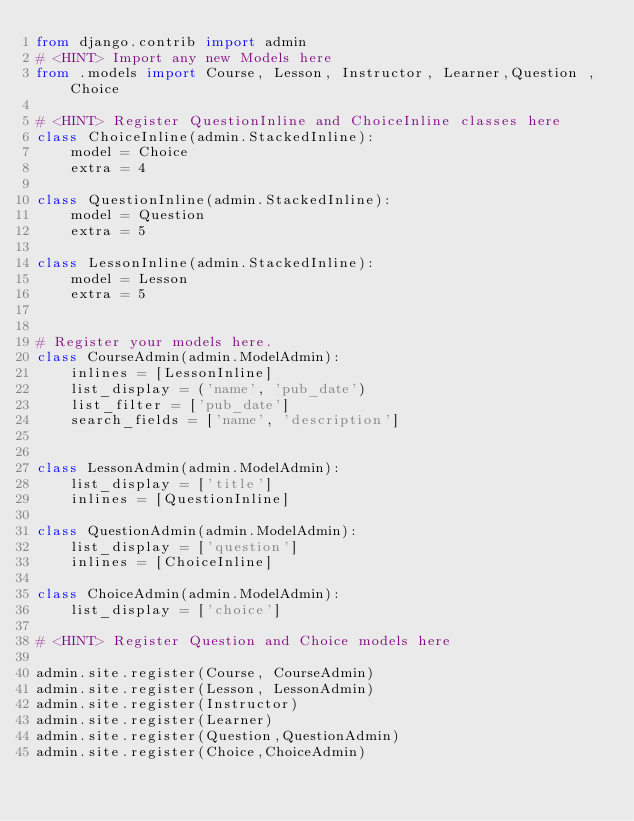Convert code to text. <code><loc_0><loc_0><loc_500><loc_500><_Python_>from django.contrib import admin
# <HINT> Import any new Models here
from .models import Course, Lesson, Instructor, Learner,Question ,Choice

# <HINT> Register QuestionInline and ChoiceInline classes here
class ChoiceInline(admin.StackedInline):
    model = Choice
    extra = 4

class QuestionInline(admin.StackedInline):
    model = Question
    extra = 5

class LessonInline(admin.StackedInline):
    model = Lesson
    extra = 5


# Register your models here.
class CourseAdmin(admin.ModelAdmin):
    inlines = [LessonInline]
    list_display = ('name', 'pub_date')
    list_filter = ['pub_date']
    search_fields = ['name', 'description']


class LessonAdmin(admin.ModelAdmin):
    list_display = ['title']
    inlines = [QuestionInline]

class QuestionAdmin(admin.ModelAdmin):
    list_display = ['question']
    inlines = [ChoiceInline]

class ChoiceAdmin(admin.ModelAdmin):
    list_display = ['choice']
       
# <HINT> Register Question and Choice models here

admin.site.register(Course, CourseAdmin)
admin.site.register(Lesson, LessonAdmin)
admin.site.register(Instructor)
admin.site.register(Learner)
admin.site.register(Question,QuestionAdmin)
admin.site.register(Choice,ChoiceAdmin)
</code> 